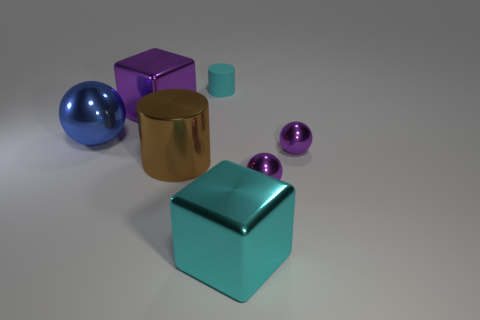Add 1 large cyan cubes. How many objects exist? 8 Subtract all cubes. How many objects are left? 5 Subtract 0 brown cubes. How many objects are left? 7 Subtract all spheres. Subtract all purple spheres. How many objects are left? 2 Add 6 big purple metal things. How many big purple metal things are left? 7 Add 3 purple objects. How many purple objects exist? 6 